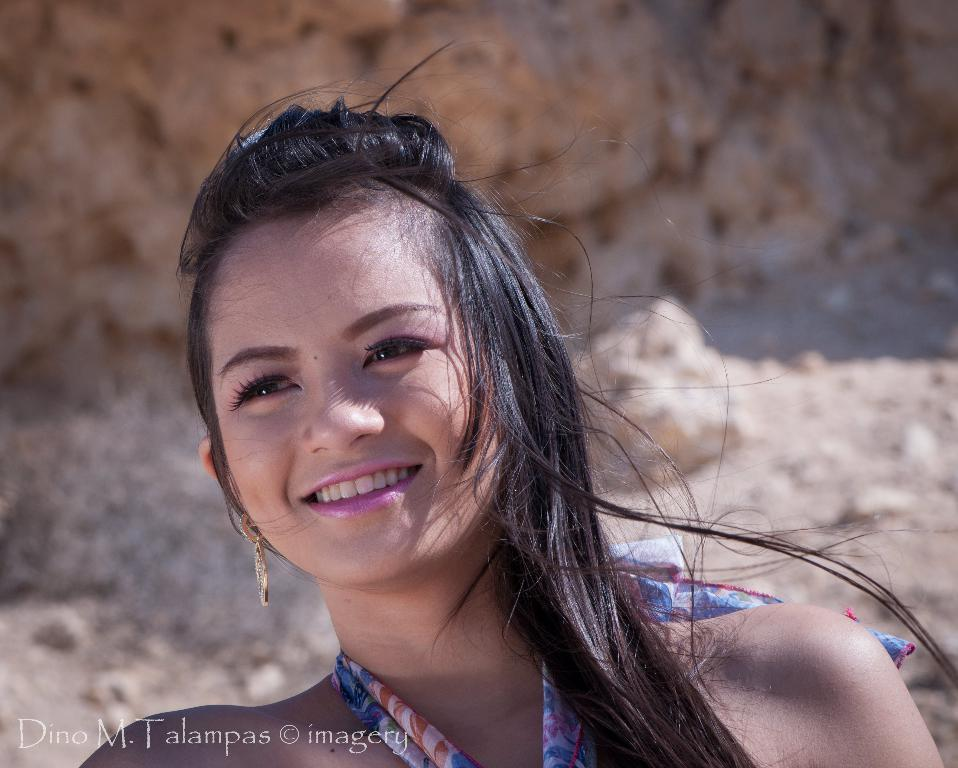Who is present in the image? There is a woman in the image. What is the woman doing in the image? The woman is smiling in the image. What can be seen in the background of the image? There are rocks in the background of the image. Is there any text visible in the image? Yes, there is some text in the bottom left of the image. How many oranges are being held by the woman in the image? There are no oranges present in the image. Can you see a key in the woman's hand in the image? There is no key visible in the woman's hand in the image. 